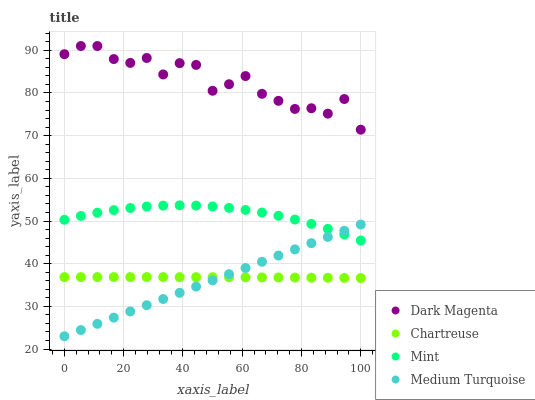Does Medium Turquoise have the minimum area under the curve?
Answer yes or no. Yes. Does Dark Magenta have the maximum area under the curve?
Answer yes or no. Yes. Does Mint have the minimum area under the curve?
Answer yes or no. No. Does Mint have the maximum area under the curve?
Answer yes or no. No. Is Medium Turquoise the smoothest?
Answer yes or no. Yes. Is Dark Magenta the roughest?
Answer yes or no. Yes. Is Mint the smoothest?
Answer yes or no. No. Is Mint the roughest?
Answer yes or no. No. Does Medium Turquoise have the lowest value?
Answer yes or no. Yes. Does Mint have the lowest value?
Answer yes or no. No. Does Dark Magenta have the highest value?
Answer yes or no. Yes. Does Mint have the highest value?
Answer yes or no. No. Is Medium Turquoise less than Dark Magenta?
Answer yes or no. Yes. Is Dark Magenta greater than Chartreuse?
Answer yes or no. Yes. Does Mint intersect Medium Turquoise?
Answer yes or no. Yes. Is Mint less than Medium Turquoise?
Answer yes or no. No. Is Mint greater than Medium Turquoise?
Answer yes or no. No. Does Medium Turquoise intersect Dark Magenta?
Answer yes or no. No. 